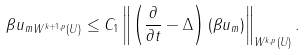<formula> <loc_0><loc_0><loc_500><loc_500>\| \beta u _ { m } \| _ { W ^ { k + 1 , p } ( U ) } \leq C _ { 1 } \left \| \left ( \frac { \partial } { \partial t } - \Delta \right ) ( \beta u _ { m } ) \right \| _ { W ^ { k , p } ( U ) } .</formula> 